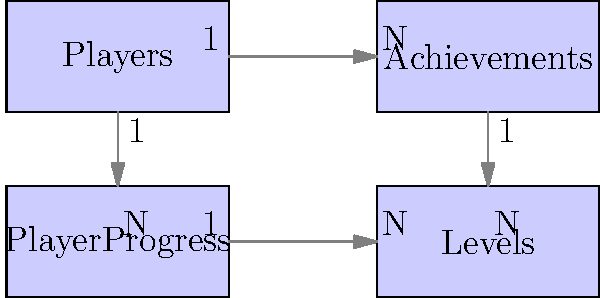Based on the database schema diagram for player progression tracking, which table would be most appropriate to store the current experience points (XP) for each player, and why? To determine the most appropriate table for storing current experience points (XP) for each player, let's analyze the schema:

1. Players table: This appears to be the main table for storing player information. However, XP is likely to change frequently and may not be a core player attribute.

2. Achievements table: This table seems to have a many-to-one relationship with Players. It's likely used to track completed achievements, not ongoing progress like XP.

3. Levels table: This table appears to define the game's level structure. It's unlikely to store player-specific information.

4. PlayerProgress table: This table has a many-to-one relationship with both Players and Levels. It's designed to track a player's progress, which aligns with storing XP.

The PlayerProgress table is the most suitable for storing current XP because:

a) It has a direct relationship with the Players table, allowing each player to have their own progress record.
b) It's linked to the Levels table, suggesting it tracks level-related information.
c) The name "PlayerProgress" implies it's meant to store dynamic, progress-related data like XP.
d) Having XP in this table allows for efficient queries related to a player's current progress and level.

Storing XP in the PlayerProgress table would allow for easy updates as the player gains experience and provides a logical place to query a player's current progress in the game.
Answer: PlayerProgress table 